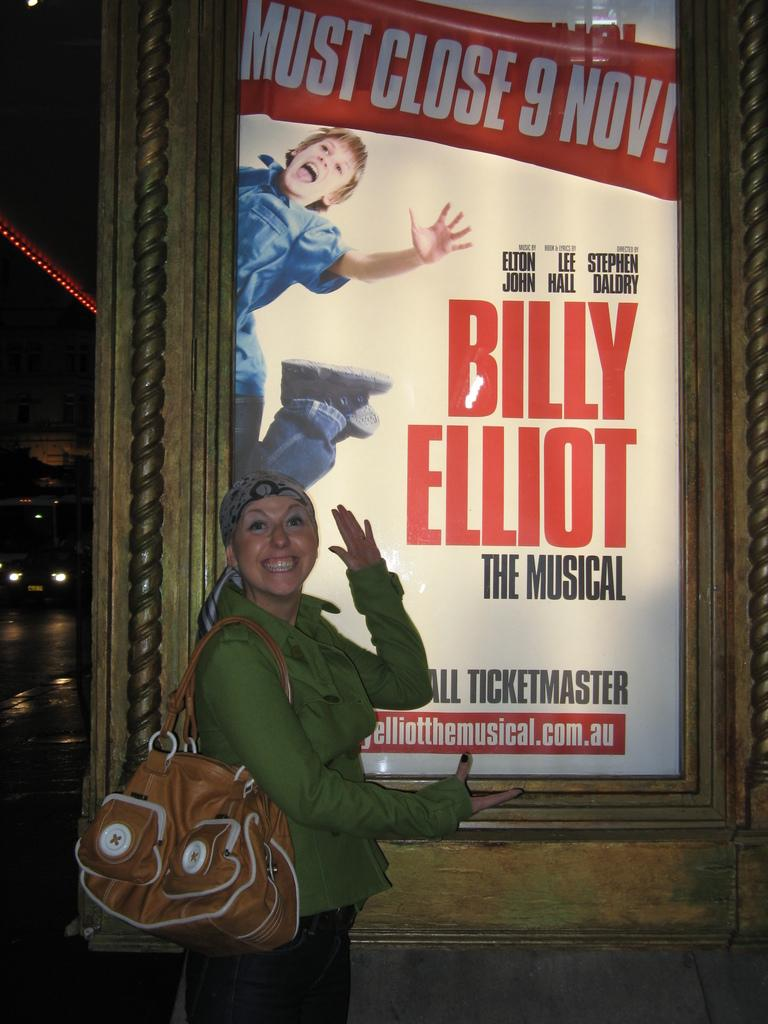Who is present in the image? There is a woman in the image. What is the woman doing in the image? The woman is standing in front of a poster. What is the woman wearing in the image? The woman is wearing a bag on her shoulder. What is the woman's facial expression in the image? The woman is smiling. What type of yam is the woman holding in the image? There is no yam present in the image; the woman is standing in front of a poster and wearing a bag on her shoulder. 